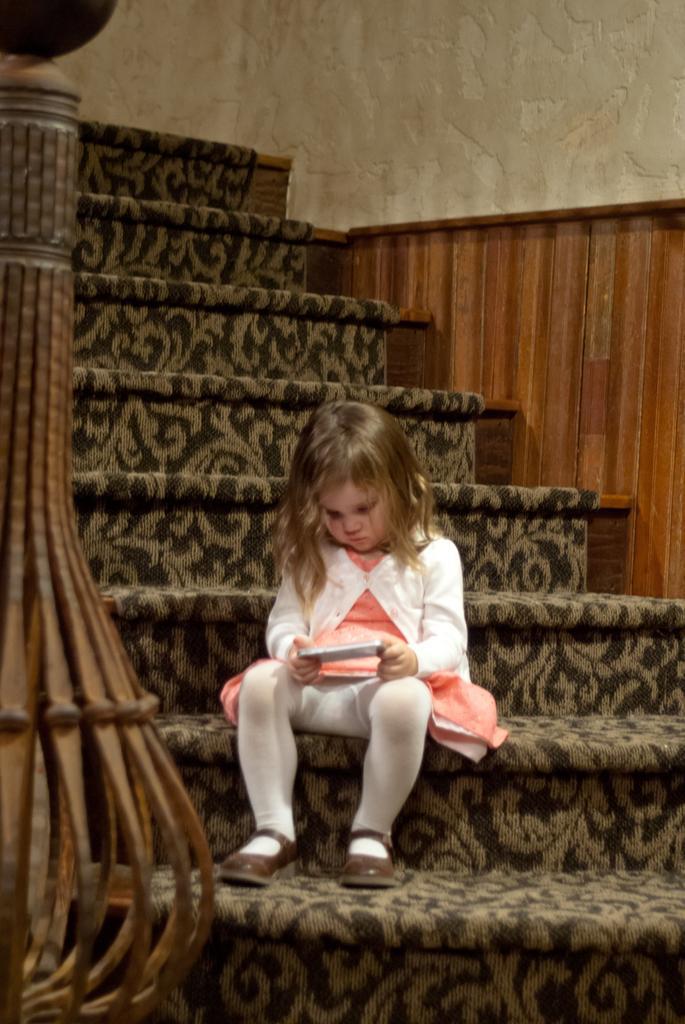Describe this image in one or two sentences. There is a girl sitting and holding object and we can see wall and steps. 